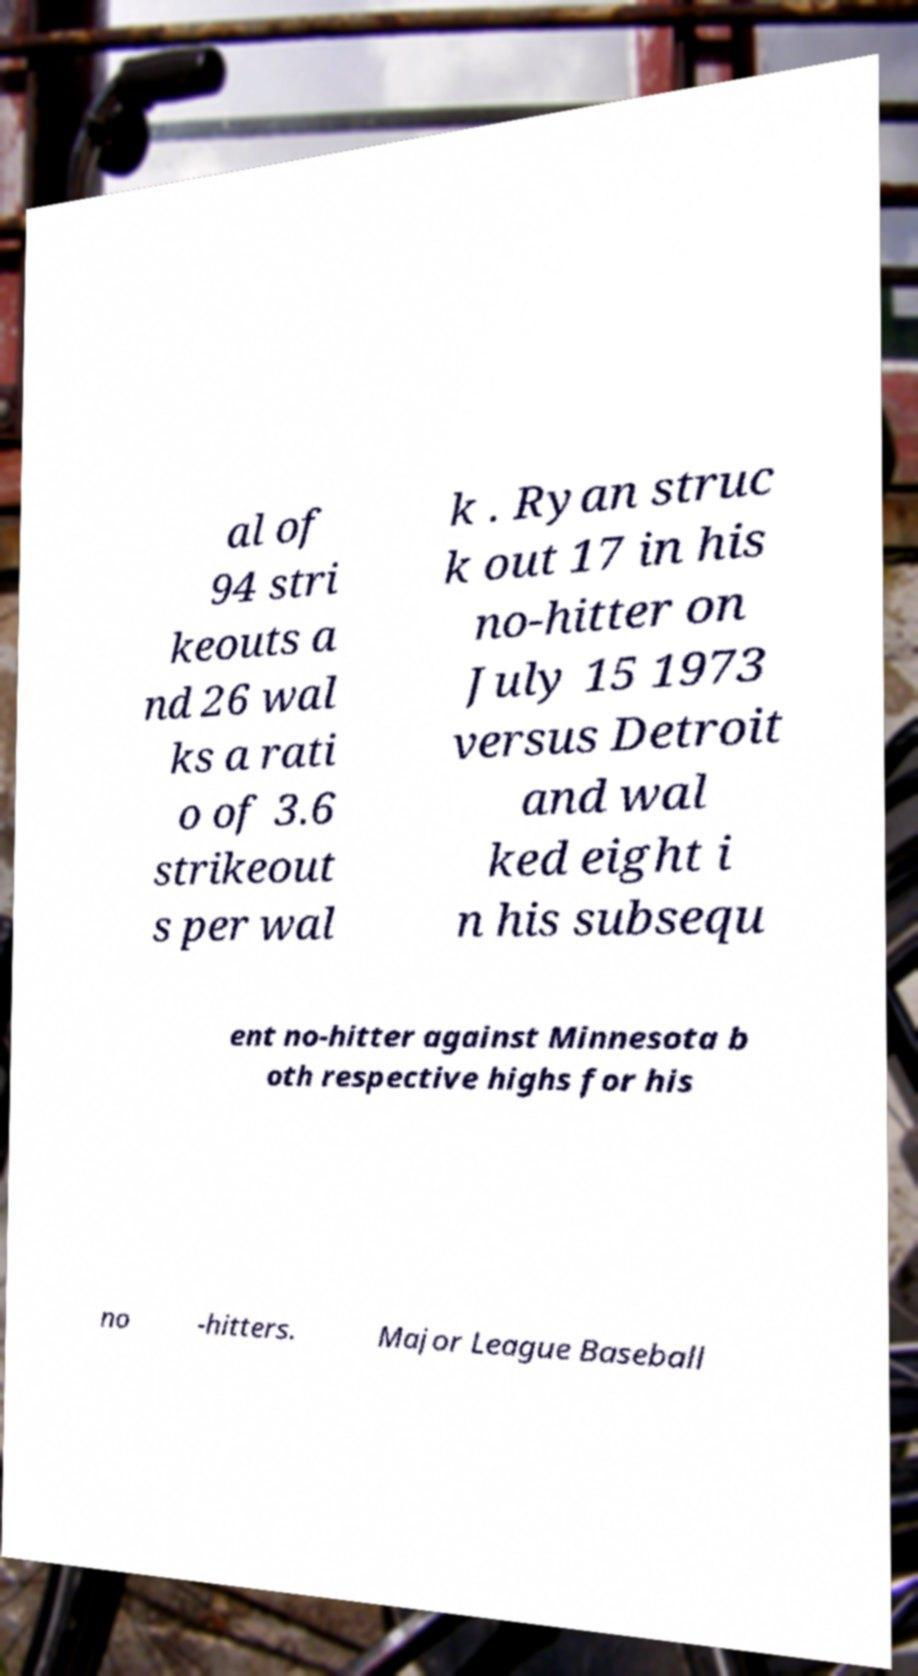There's text embedded in this image that I need extracted. Can you transcribe it verbatim? al of 94 stri keouts a nd 26 wal ks a rati o of 3.6 strikeout s per wal k . Ryan struc k out 17 in his no-hitter on July 15 1973 versus Detroit and wal ked eight i n his subsequ ent no-hitter against Minnesota b oth respective highs for his no -hitters. Major League Baseball 